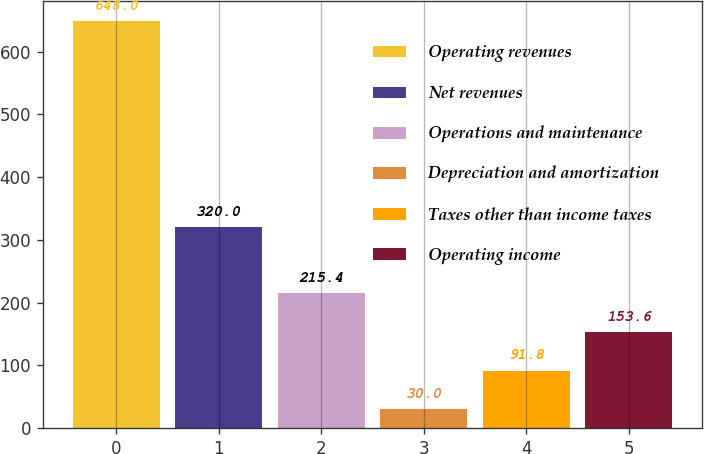Convert chart to OTSL. <chart><loc_0><loc_0><loc_500><loc_500><bar_chart><fcel>Operating revenues<fcel>Net revenues<fcel>Operations and maintenance<fcel>Depreciation and amortization<fcel>Taxes other than income taxes<fcel>Operating income<nl><fcel>648<fcel>320<fcel>215.4<fcel>30<fcel>91.8<fcel>153.6<nl></chart> 